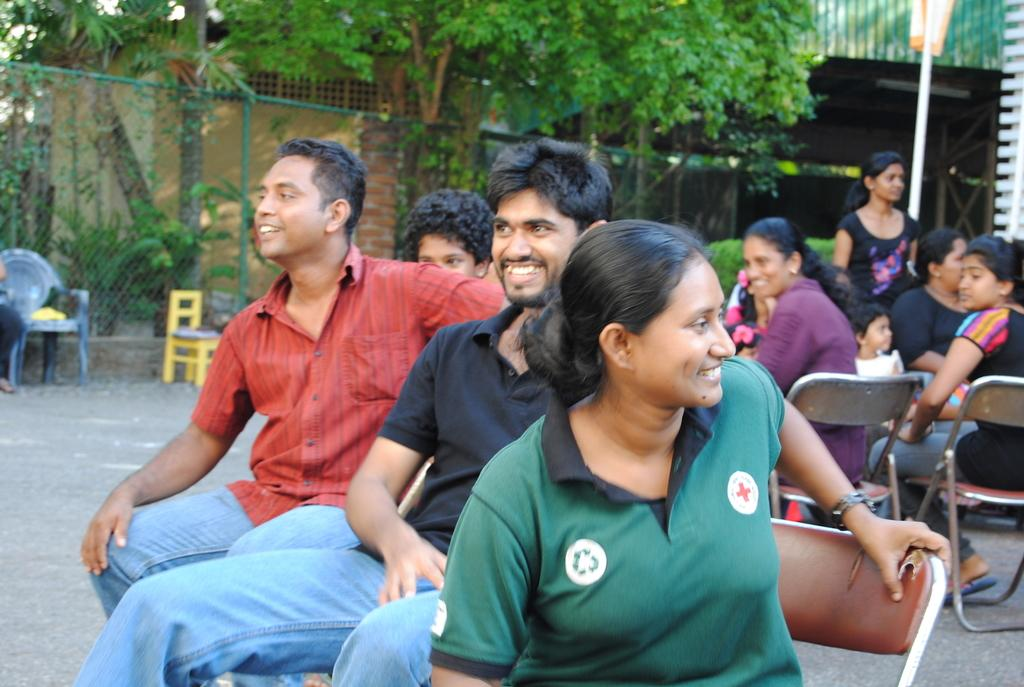How many people are in the image? There is a group of people in the image. What are the people in the image doing? The people are sitting and smiling. What can be seen in the background of the image? There is a pole, plants, and a fence in the background of the image. How many hands are visible in the image? There is no specific mention of hands in the image, so it is not possible to determine the number of hands visible. 